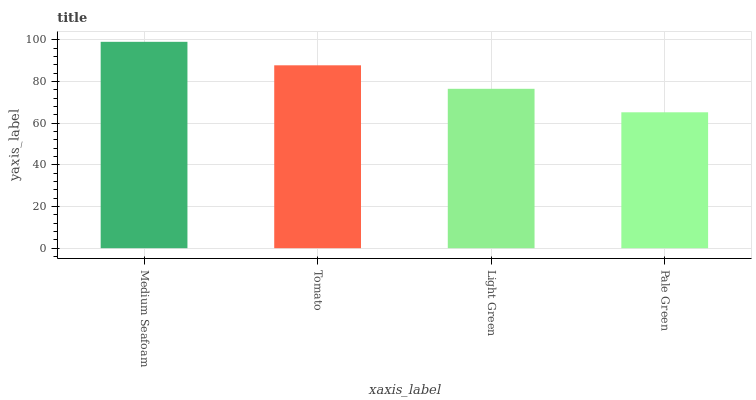Is Pale Green the minimum?
Answer yes or no. Yes. Is Medium Seafoam the maximum?
Answer yes or no. Yes. Is Tomato the minimum?
Answer yes or no. No. Is Tomato the maximum?
Answer yes or no. No. Is Medium Seafoam greater than Tomato?
Answer yes or no. Yes. Is Tomato less than Medium Seafoam?
Answer yes or no. Yes. Is Tomato greater than Medium Seafoam?
Answer yes or no. No. Is Medium Seafoam less than Tomato?
Answer yes or no. No. Is Tomato the high median?
Answer yes or no. Yes. Is Light Green the low median?
Answer yes or no. Yes. Is Pale Green the high median?
Answer yes or no. No. Is Tomato the low median?
Answer yes or no. No. 